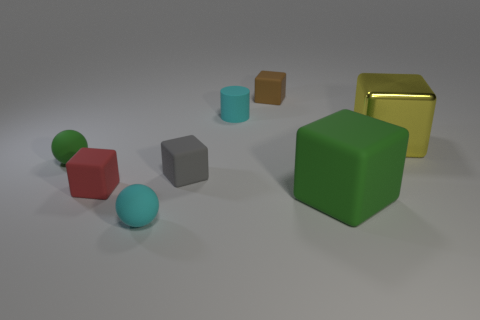Are there any other things that have the same material as the yellow thing?
Offer a very short reply. No. There is a small object that is the same color as the rubber cylinder; what material is it?
Your answer should be very brief. Rubber. Is the small cyan thing that is behind the red rubber thing made of the same material as the large yellow object?
Offer a terse response. No. Is there a tiny ball that has the same color as the cylinder?
Provide a short and direct response. Yes. What is the shape of the gray thing?
Offer a very short reply. Cube. There is a tiny matte thing that is behind the cyan object that is behind the large yellow shiny object; what is its color?
Your answer should be very brief. Brown. There is a matte block behind the yellow object; how big is it?
Give a very brief answer. Small. Is there a brown object made of the same material as the cyan cylinder?
Ensure brevity in your answer.  Yes. What number of large green objects have the same shape as the small red rubber object?
Provide a succinct answer. 1. What is the shape of the green thing to the right of the green object that is on the left side of the tiny matte object behind the tiny cyan matte cylinder?
Ensure brevity in your answer.  Cube. 